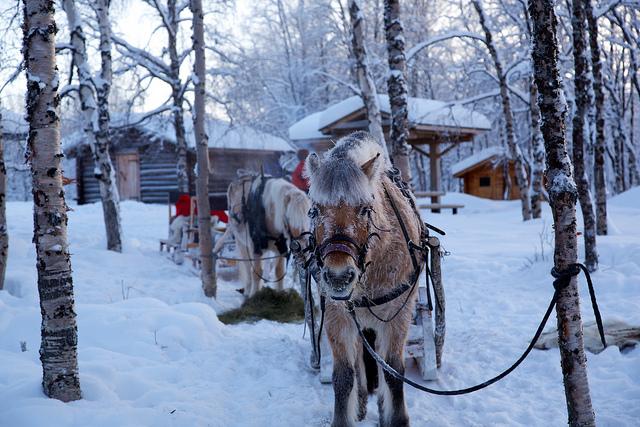How many horses are there?
Keep it brief. 2. What season is this?
Answer briefly. Winter. Is that snow on the ground?
Keep it brief. Yes. 